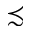<formula> <loc_0><loc_0><loc_500><loc_500>\prec s i m</formula> 